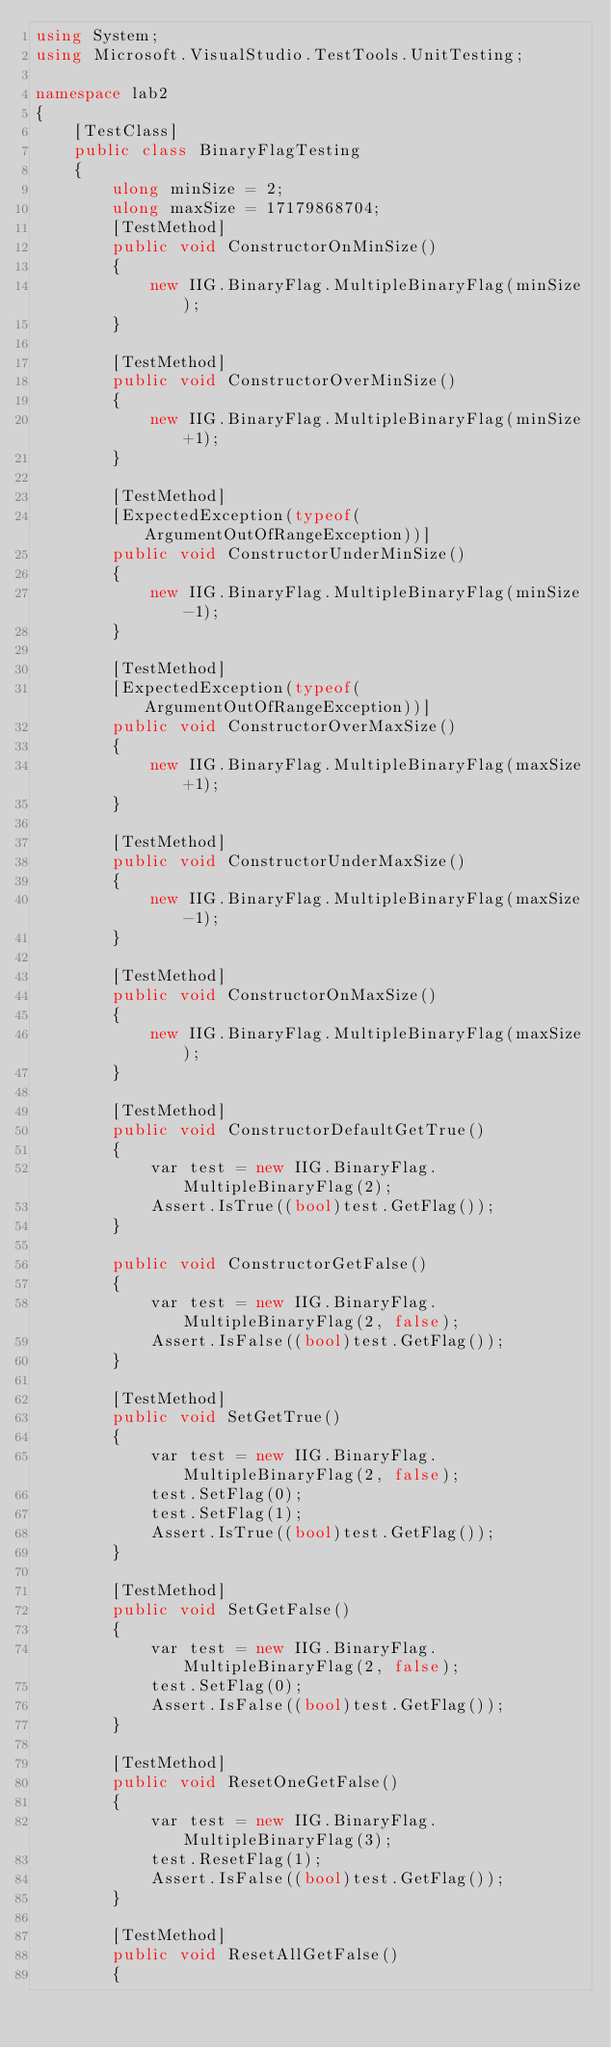Convert code to text. <code><loc_0><loc_0><loc_500><loc_500><_C#_>using System;
using Microsoft.VisualStudio.TestTools.UnitTesting;

namespace lab2
{
    [TestClass]
    public class BinaryFlagTesting
    {
        ulong minSize = 2;
        ulong maxSize = 17179868704;
        [TestMethod]
        public void ConstructorOnMinSize()
        {
            new IIG.BinaryFlag.MultipleBinaryFlag(minSize);
        }

        [TestMethod]
        public void ConstructorOverMinSize()
        {
            new IIG.BinaryFlag.MultipleBinaryFlag(minSize+1);
        }

        [TestMethod]
        [ExpectedException(typeof(ArgumentOutOfRangeException))]
        public void ConstructorUnderMinSize()
        {
            new IIG.BinaryFlag.MultipleBinaryFlag(minSize-1);
        }

        [TestMethod]
        [ExpectedException(typeof(ArgumentOutOfRangeException))]
        public void ConstructorOverMaxSize()
        {
            new IIG.BinaryFlag.MultipleBinaryFlag(maxSize+1);
        }

        [TestMethod]
        public void ConstructorUnderMaxSize()
        {
            new IIG.BinaryFlag.MultipleBinaryFlag(maxSize-1);
        }

        [TestMethod]
        public void ConstructorOnMaxSize()
        {
            new IIG.BinaryFlag.MultipleBinaryFlag(maxSize);
        }

        [TestMethod]
        public void ConstructorDefaultGetTrue()
        {
            var test = new IIG.BinaryFlag.MultipleBinaryFlag(2);
            Assert.IsTrue((bool)test.GetFlag());
        }

        public void ConstructorGetFalse()
        {
            var test = new IIG.BinaryFlag.MultipleBinaryFlag(2, false);
            Assert.IsFalse((bool)test.GetFlag());
        }

        [TestMethod]
        public void SetGetTrue()
        {
            var test = new IIG.BinaryFlag.MultipleBinaryFlag(2, false);
            test.SetFlag(0);
            test.SetFlag(1);
            Assert.IsTrue((bool)test.GetFlag());
        }

        [TestMethod]
        public void SetGetFalse()
        {
            var test = new IIG.BinaryFlag.MultipleBinaryFlag(2, false);
            test.SetFlag(0);
            Assert.IsFalse((bool)test.GetFlag());
        }

        [TestMethod]
        public void ResetOneGetFalse()
        {
            var test = new IIG.BinaryFlag.MultipleBinaryFlag(3);
            test.ResetFlag(1);
            Assert.IsFalse((bool)test.GetFlag());
        }

        [TestMethod]
        public void ResetAllGetFalse()
        {</code> 